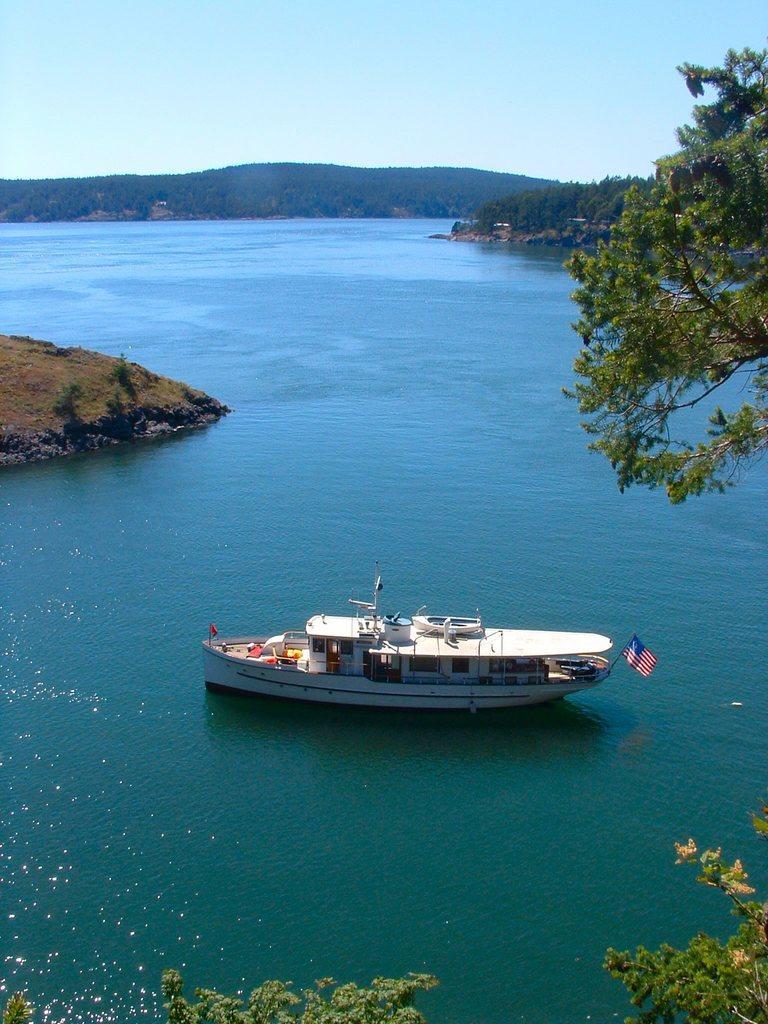Could you give a brief overview of what you see in this image? In the center of the image, we can see a boat on the water and in the background, there are trees and hills. 